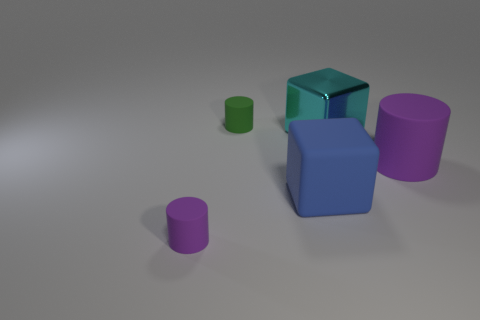There is another cylinder that is the same color as the big rubber cylinder; what material is it?
Offer a very short reply. Rubber. Is the number of tiny rubber objects that are in front of the cyan metal block greater than the number of small gray rubber balls?
Keep it short and to the point. Yes. There is a object that is behind the large purple matte thing and left of the large cyan cube; what is its size?
Your response must be concise. Small. What is the shape of the object that is to the left of the big blue rubber cube and on the right side of the small purple cylinder?
Give a very brief answer. Cylinder. Are there any large blue matte things that are behind the purple rubber object on the left side of the big object that is on the right side of the big metal cube?
Give a very brief answer. Yes. How many things are either rubber cylinders that are behind the small purple rubber object or small rubber things in front of the cyan object?
Provide a short and direct response. 3. Do the purple object that is on the right side of the small green rubber thing and the big blue thing have the same material?
Your response must be concise. Yes. The cylinder that is in front of the green cylinder and on the left side of the blue thing is made of what material?
Your response must be concise. Rubber. There is a tiny rubber object behind the big rubber thing that is on the left side of the cyan metallic cube; what is its color?
Ensure brevity in your answer.  Green. What is the material of the large object that is the same shape as the small green rubber object?
Offer a very short reply. Rubber. 